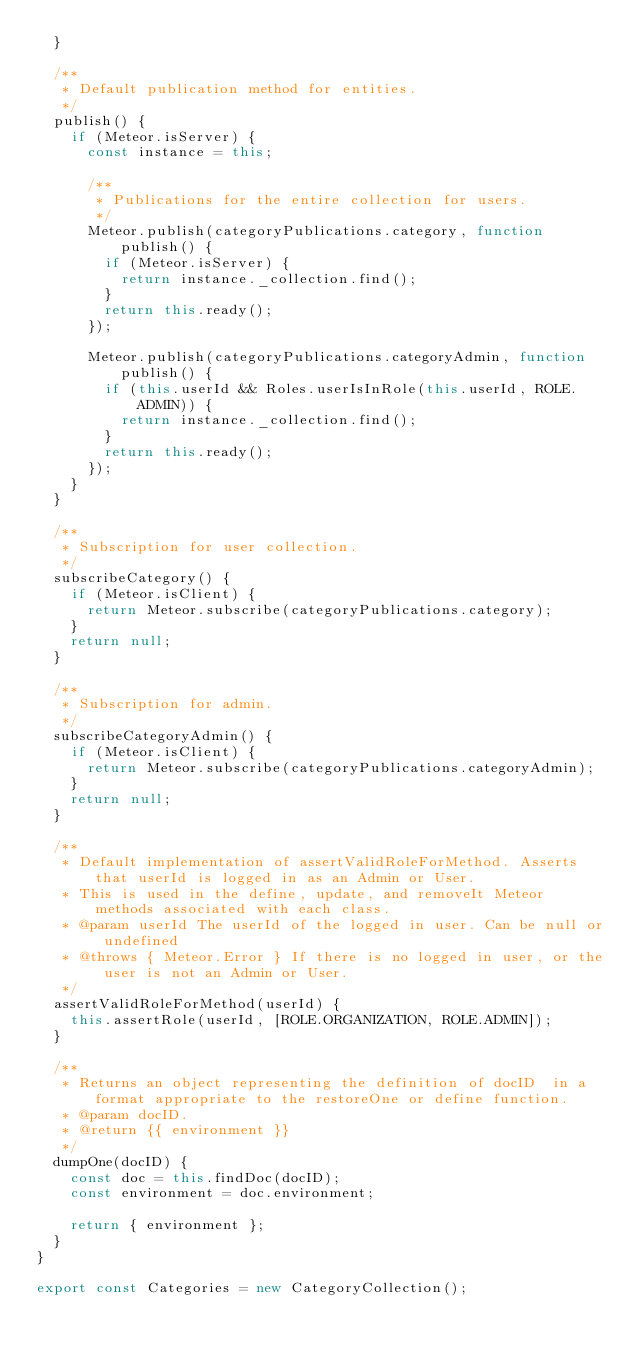Convert code to text. <code><loc_0><loc_0><loc_500><loc_500><_JavaScript_>  }

  /**
   * Default publication method for entities.
   */
  publish() {
    if (Meteor.isServer) {
      const instance = this;

      /**
       * Publications for the entire collection for users.
       */
      Meteor.publish(categoryPublications.category, function publish() {
        if (Meteor.isServer) {
          return instance._collection.find();
        }
        return this.ready();
      });

      Meteor.publish(categoryPublications.categoryAdmin, function publish() {
        if (this.userId && Roles.userIsInRole(this.userId, ROLE.ADMIN)) {
          return instance._collection.find();
        }
        return this.ready();
      });
    }
  }

  /**
   * Subscription for user collection.
   */
  subscribeCategory() {
    if (Meteor.isClient) {
      return Meteor.subscribe(categoryPublications.category);
    }
    return null;
  }

  /**
   * Subscription for admin.
   */
  subscribeCategoryAdmin() {
    if (Meteor.isClient) {
      return Meteor.subscribe(categoryPublications.categoryAdmin);
    }
    return null;
  }

  /**
   * Default implementation of assertValidRoleForMethod. Asserts that userId is logged in as an Admin or User.
   * This is used in the define, update, and removeIt Meteor methods associated with each class.
   * @param userId The userId of the logged in user. Can be null or undefined
   * @throws { Meteor.Error } If there is no logged in user, or the user is not an Admin or User.
   */
  assertValidRoleForMethod(userId) {
    this.assertRole(userId, [ROLE.ORGANIZATION, ROLE.ADMIN]);
  }

  /**
   * Returns an object representing the definition of docID  in a format appropriate to the restoreOne or define function.
   * @param docID.
   * @return {{ environment }}
   */
  dumpOne(docID) {
    const doc = this.findDoc(docID);
    const environment = doc.environment;

    return { environment };
  }
}

export const Categories = new CategoryCollection();
</code> 